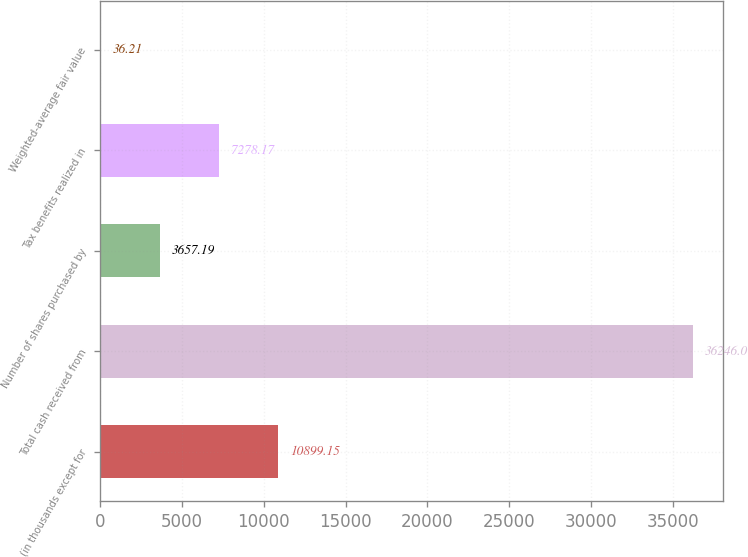Convert chart. <chart><loc_0><loc_0><loc_500><loc_500><bar_chart><fcel>(in thousands except for<fcel>Total cash received from<fcel>Number of shares purchased by<fcel>Tax benefits realized in<fcel>Weighted-average fair value<nl><fcel>10899.1<fcel>36246<fcel>3657.19<fcel>7278.17<fcel>36.21<nl></chart> 